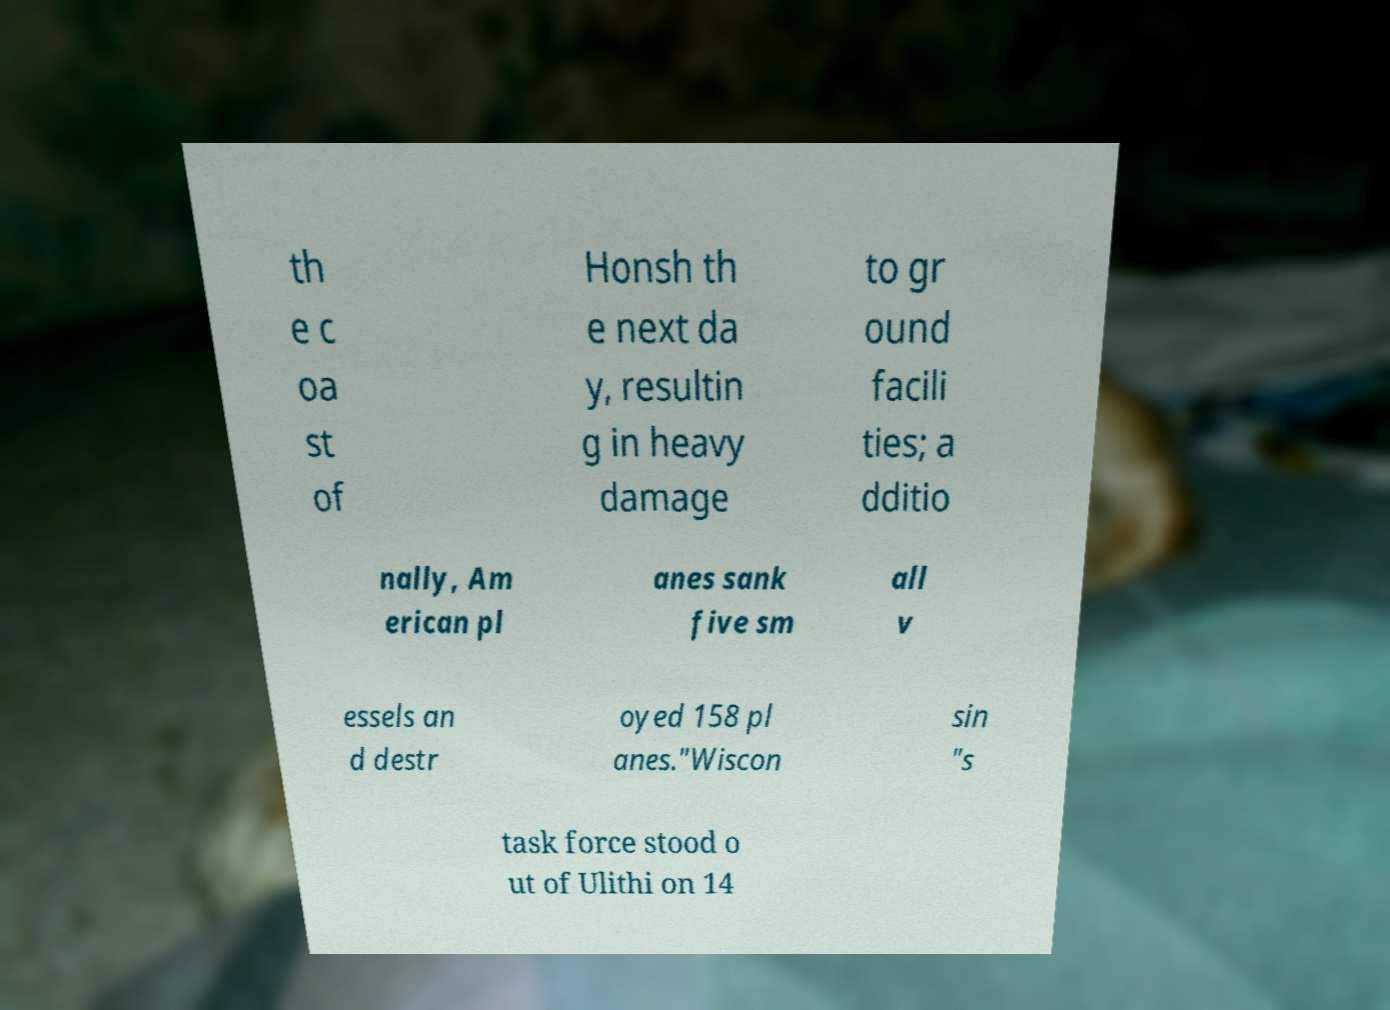Can you accurately transcribe the text from the provided image for me? th e c oa st of Honsh th e next da y, resultin g in heavy damage to gr ound facili ties; a dditio nally, Am erican pl anes sank five sm all v essels an d destr oyed 158 pl anes."Wiscon sin "s task force stood o ut of Ulithi on 14 